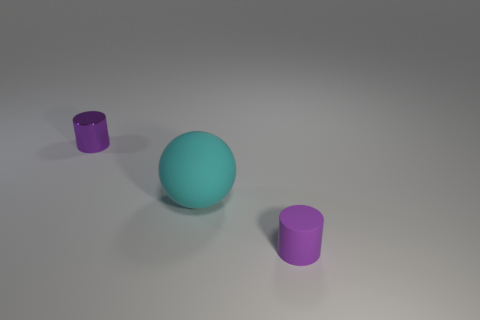Subtract all purple cylinders. How many were subtracted if there are1purple cylinders left? 1 Subtract 2 cylinders. How many cylinders are left? 0 Subtract all gray spheres. Subtract all gray cylinders. How many spheres are left? 1 Subtract all small rubber things. Subtract all purple things. How many objects are left? 0 Add 2 large matte balls. How many large matte balls are left? 3 Add 3 purple cylinders. How many purple cylinders exist? 5 Add 3 small rubber cylinders. How many objects exist? 6 Subtract 2 purple cylinders. How many objects are left? 1 Subtract all balls. How many objects are left? 2 